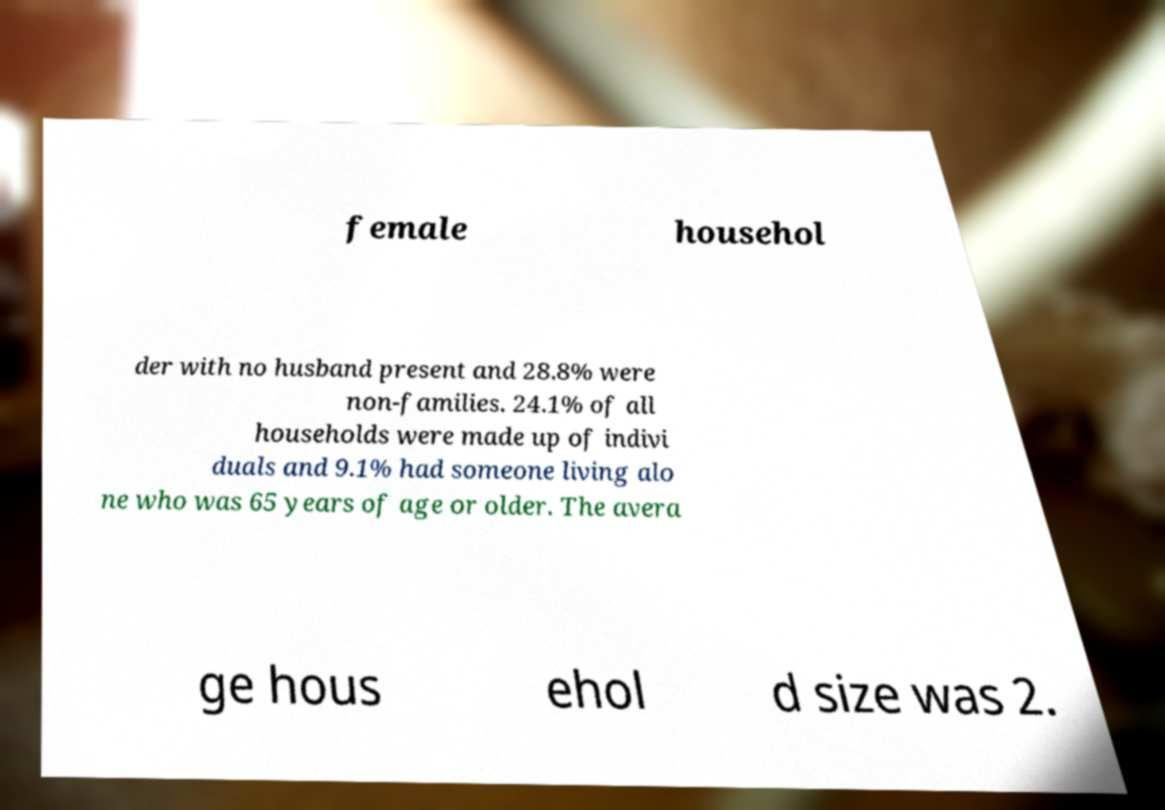What messages or text are displayed in this image? I need them in a readable, typed format. female househol der with no husband present and 28.8% were non-families. 24.1% of all households were made up of indivi duals and 9.1% had someone living alo ne who was 65 years of age or older. The avera ge hous ehol d size was 2. 